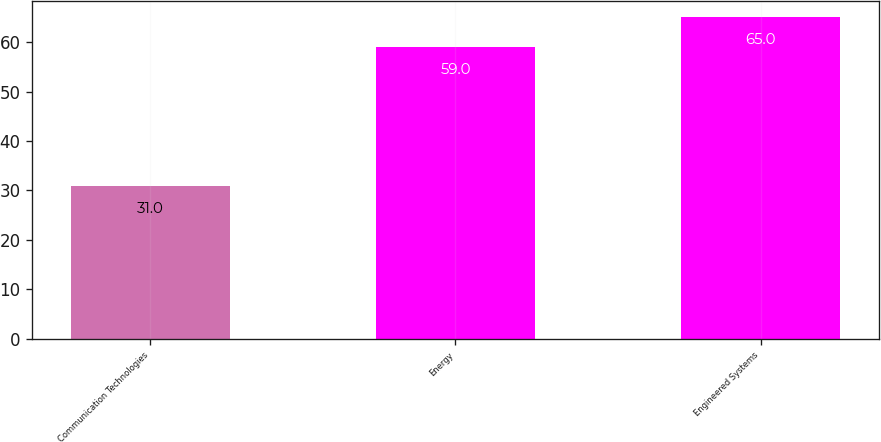<chart> <loc_0><loc_0><loc_500><loc_500><bar_chart><fcel>Communication Technologies<fcel>Energy<fcel>Engineered Systems<nl><fcel>31<fcel>59<fcel>65<nl></chart> 